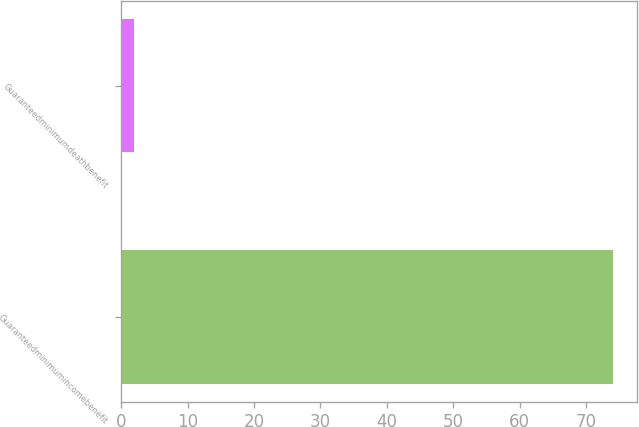<chart> <loc_0><loc_0><loc_500><loc_500><bar_chart><fcel>Guaranteedminimumincomebenefit<fcel>Guaranteedminimumdeathbenefit<nl><fcel>74<fcel>2<nl></chart> 